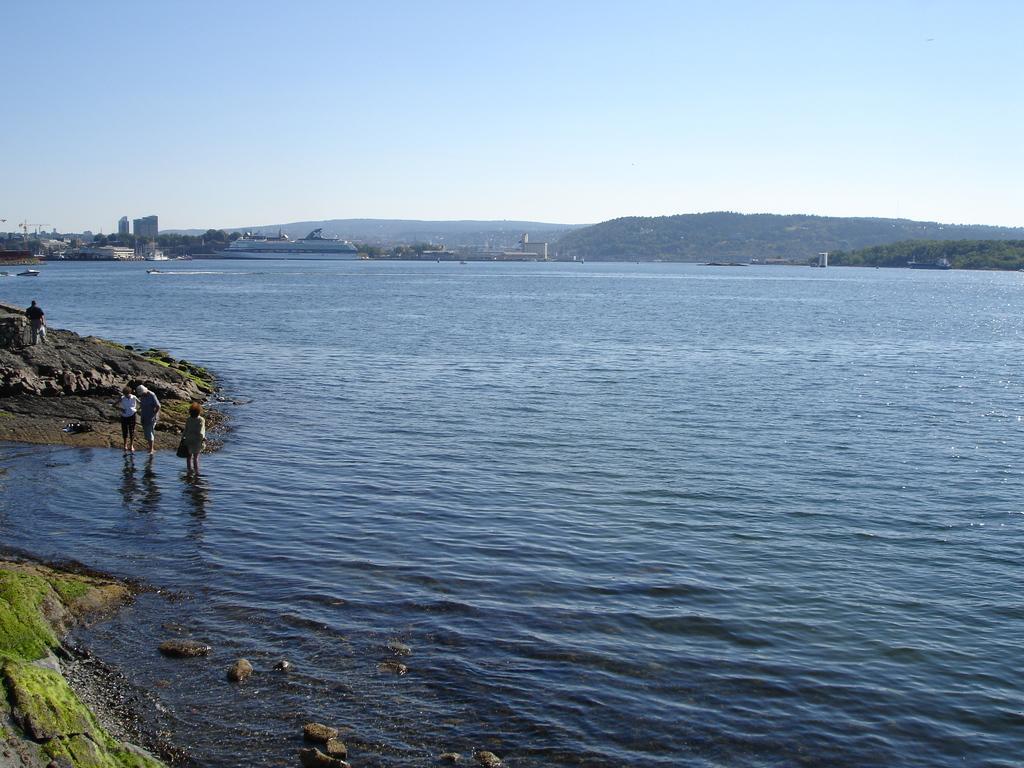In one or two sentences, can you explain what this image depicts? On the left side of the image there are three people standing in the water and a person is standing on the rock. At the center of the image there are few boats on the river. In the background there are buildings, mountains and a sky. 